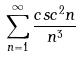<formula> <loc_0><loc_0><loc_500><loc_500>\sum _ { n = 1 } ^ { \infty } \frac { c s c ^ { 2 } n } { n ^ { 3 } }</formula> 